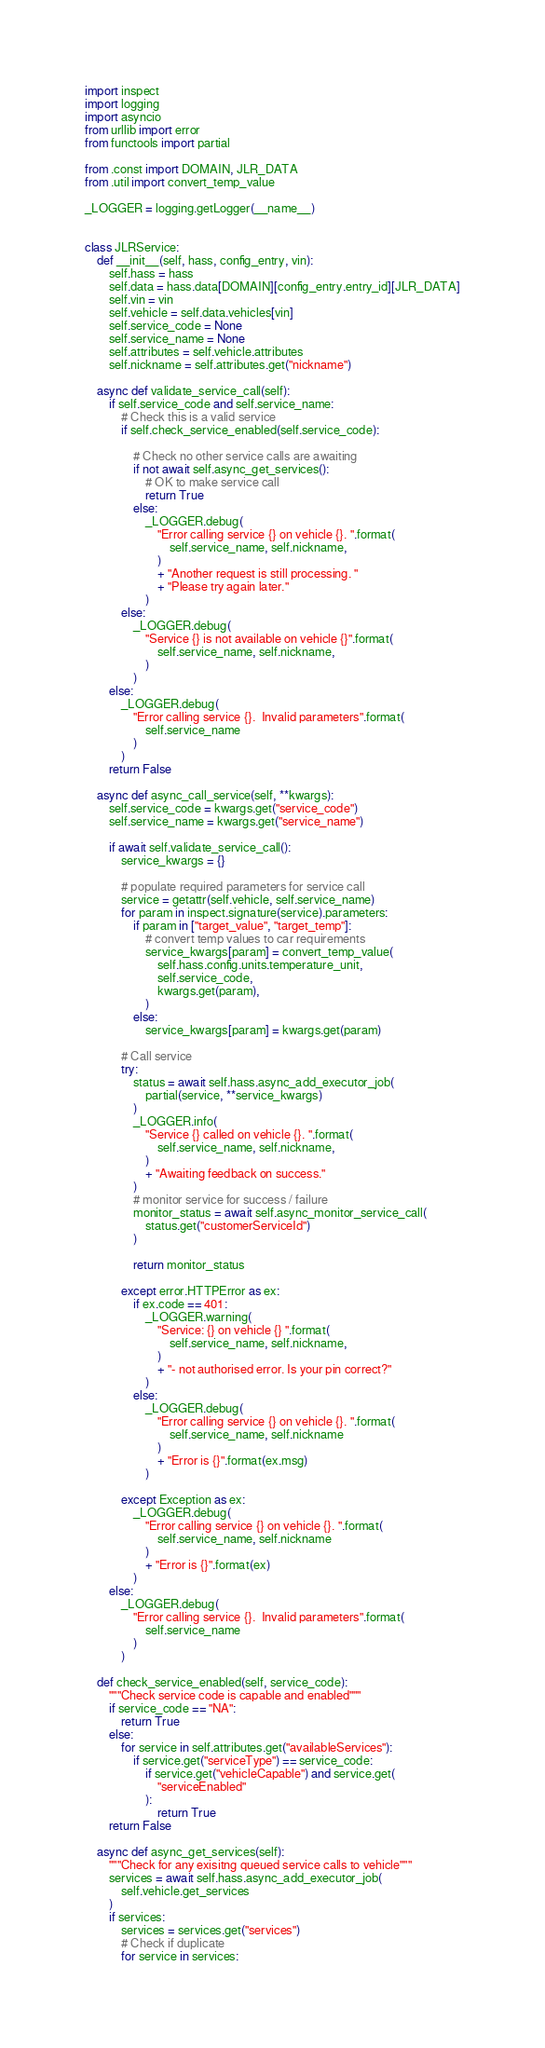<code> <loc_0><loc_0><loc_500><loc_500><_Python_>import inspect
import logging
import asyncio
from urllib import error
from functools import partial

from .const import DOMAIN, JLR_DATA
from .util import convert_temp_value

_LOGGER = logging.getLogger(__name__)


class JLRService:
    def __init__(self, hass, config_entry, vin):
        self.hass = hass
        self.data = hass.data[DOMAIN][config_entry.entry_id][JLR_DATA]
        self.vin = vin
        self.vehicle = self.data.vehicles[vin]
        self.service_code = None
        self.service_name = None
        self.attributes = self.vehicle.attributes
        self.nickname = self.attributes.get("nickname")

    async def validate_service_call(self):
        if self.service_code and self.service_name:
            # Check this is a valid service
            if self.check_service_enabled(self.service_code):

                # Check no other service calls are awaiting
                if not await self.async_get_services():
                    # OK to make service call
                    return True
                else:
                    _LOGGER.debug(
                        "Error calling service {} on vehicle {}. ".format(
                            self.service_name, self.nickname,
                        )
                        + "Another request is still processing. "
                        + "Please try again later."
                    )
            else:
                _LOGGER.debug(
                    "Service {} is not available on vehicle {}".format(
                        self.service_name, self.nickname,
                    )
                )
        else:
            _LOGGER.debug(
                "Error calling service {}.  Invalid parameters".format(
                    self.service_name
                )
            )
        return False

    async def async_call_service(self, **kwargs):
        self.service_code = kwargs.get("service_code")
        self.service_name = kwargs.get("service_name")

        if await self.validate_service_call():
            service_kwargs = {}

            # populate required parameters for service call
            service = getattr(self.vehicle, self.service_name)
            for param in inspect.signature(service).parameters:
                if param in ["target_value", "target_temp"]:
                    # convert temp values to car requirements
                    service_kwargs[param] = convert_temp_value(
                        self.hass.config.units.temperature_unit,
                        self.service_code,
                        kwargs.get(param),
                    )
                else:
                    service_kwargs[param] = kwargs.get(param)

            # Call service
            try:
                status = await self.hass.async_add_executor_job(
                    partial(service, **service_kwargs)
                )
                _LOGGER.info(
                    "Service {} called on vehicle {}. ".format(
                        self.service_name, self.nickname,
                    )
                    + "Awaiting feedback on success."
                )
                # monitor service for success / failure
                monitor_status = await self.async_monitor_service_call(
                    status.get("customerServiceId")
                )

                return monitor_status

            except error.HTTPError as ex:
                if ex.code == 401:
                    _LOGGER.warning(
                        "Service: {} on vehicle {} ".format(
                            self.service_name, self.nickname,
                        )
                        + "- not authorised error. Is your pin correct?"
                    )
                else:
                    _LOGGER.debug(
                        "Error calling service {} on vehicle {}. ".format(
                            self.service_name, self.nickname
                        )
                        + "Error is {}".format(ex.msg)
                    )

            except Exception as ex:
                _LOGGER.debug(
                    "Error calling service {} on vehicle {}. ".format(
                        self.service_name, self.nickname
                    )
                    + "Error is {}".format(ex)
                )
        else:
            _LOGGER.debug(
                "Error calling service {}.  Invalid parameters".format(
                    self.service_name
                )
            )

    def check_service_enabled(self, service_code):
        """Check service code is capable and enabled"""
        if service_code == "NA":
            return True
        else:
            for service in self.attributes.get("availableServices"):
                if service.get("serviceType") == service_code:
                    if service.get("vehicleCapable") and service.get(
                        "serviceEnabled"
                    ):
                        return True
        return False

    async def async_get_services(self):
        """Check for any exisitng queued service calls to vehicle"""
        services = await self.hass.async_add_executor_job(
            self.vehicle.get_services
        )
        if services:
            services = services.get("services")
            # Check if duplicate
            for service in services:</code> 